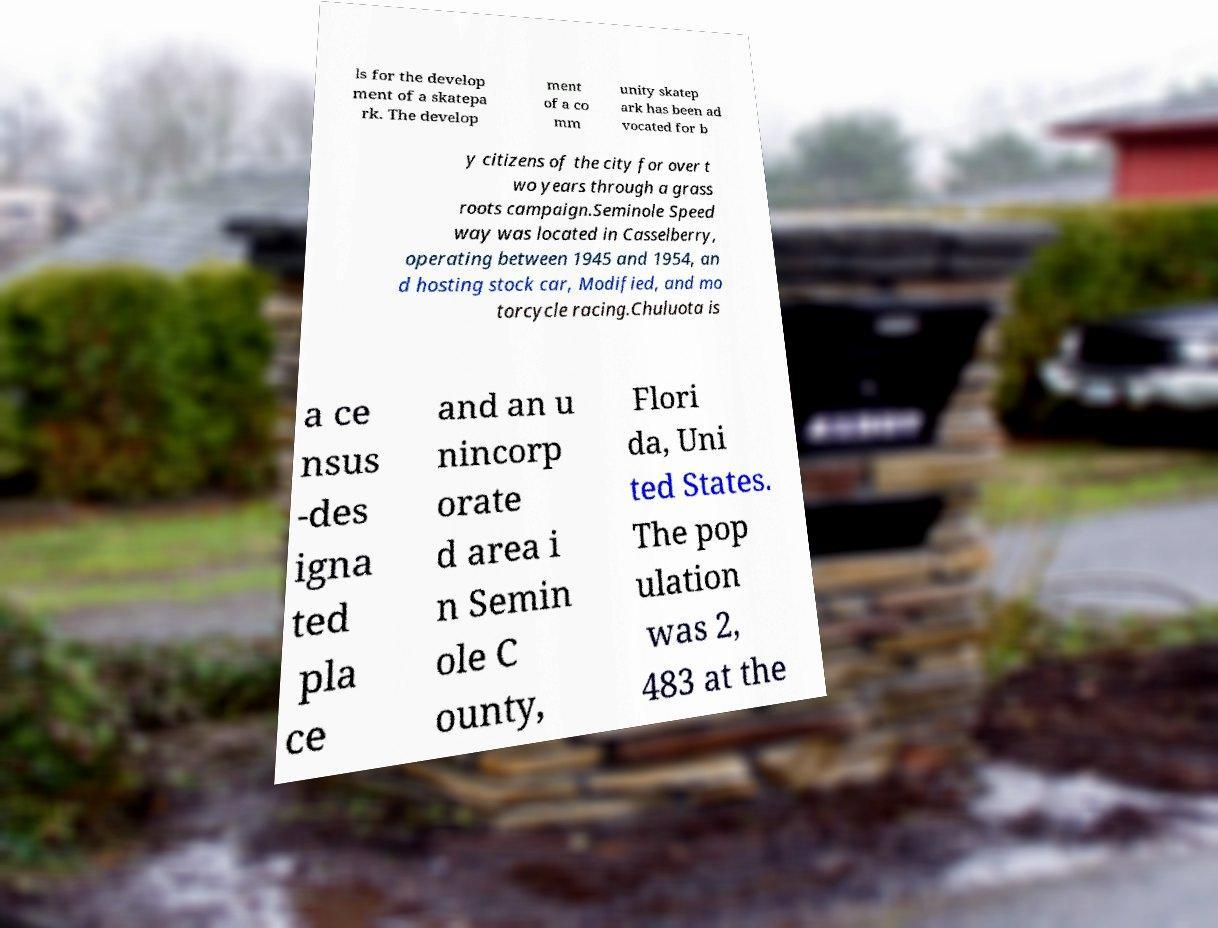Could you assist in decoding the text presented in this image and type it out clearly? ls for the develop ment of a skatepa rk. The develop ment of a co mm unity skatep ark has been ad vocated for b y citizens of the city for over t wo years through a grass roots campaign.Seminole Speed way was located in Casselberry, operating between 1945 and 1954, an d hosting stock car, Modified, and mo torcycle racing.Chuluota is a ce nsus -des igna ted pla ce and an u nincorp orate d area i n Semin ole C ounty, Flori da, Uni ted States. The pop ulation was 2, 483 at the 